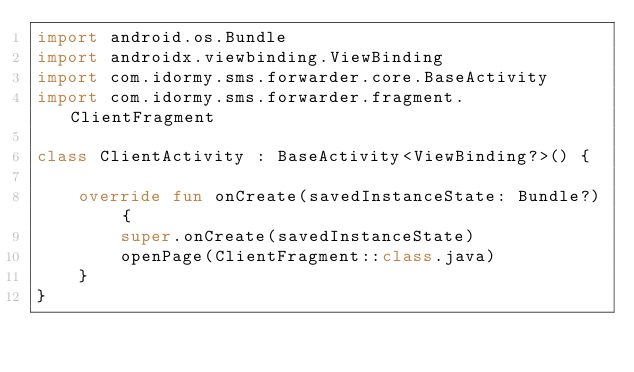<code> <loc_0><loc_0><loc_500><loc_500><_Kotlin_>import android.os.Bundle
import androidx.viewbinding.ViewBinding
import com.idormy.sms.forwarder.core.BaseActivity
import com.idormy.sms.forwarder.fragment.ClientFragment

class ClientActivity : BaseActivity<ViewBinding?>() {

    override fun onCreate(savedInstanceState: Bundle?) {
        super.onCreate(savedInstanceState)
        openPage(ClientFragment::class.java)
    }
}</code> 